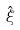Convert formula to latex. <formula><loc_0><loc_0><loc_500><loc_500>\hat { \xi }</formula> 